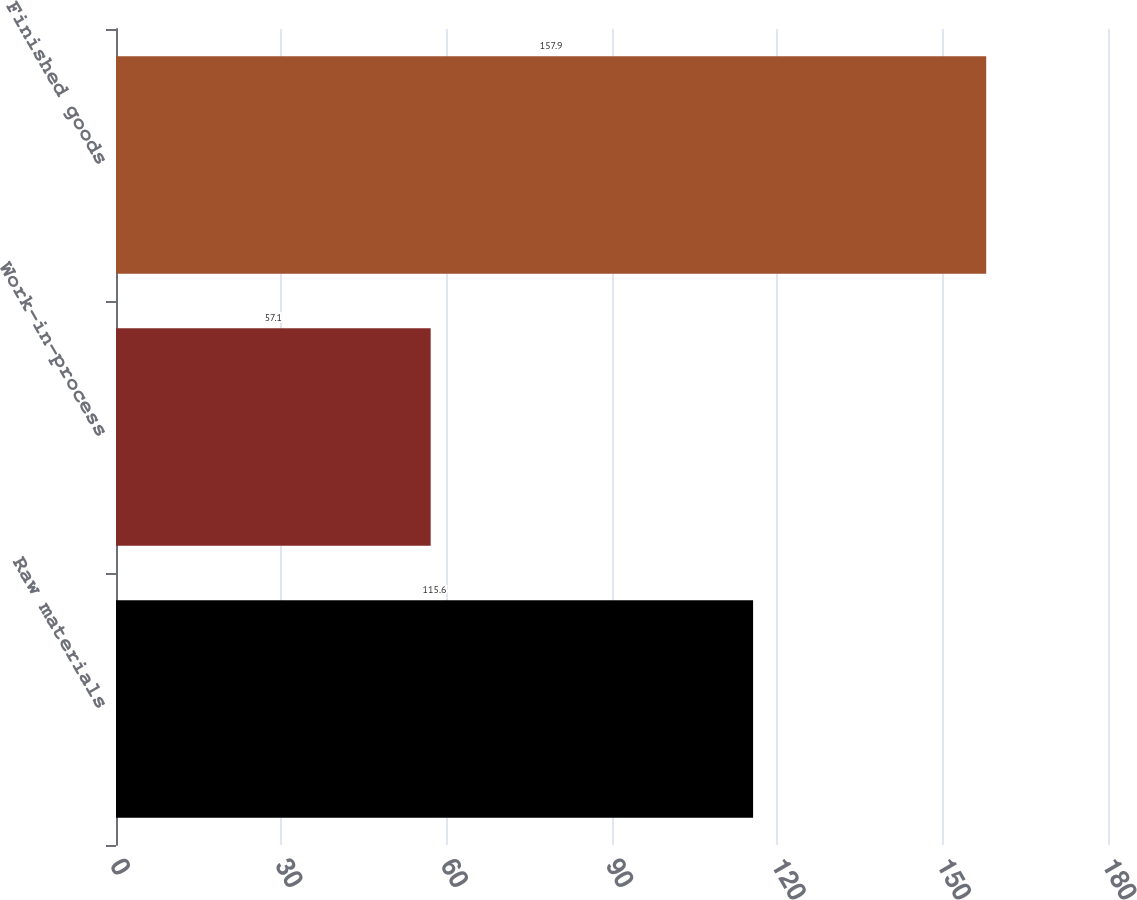<chart> <loc_0><loc_0><loc_500><loc_500><bar_chart><fcel>Raw materials<fcel>Work-in-process<fcel>Finished goods<nl><fcel>115.6<fcel>57.1<fcel>157.9<nl></chart> 